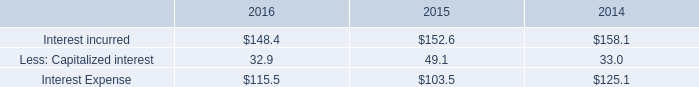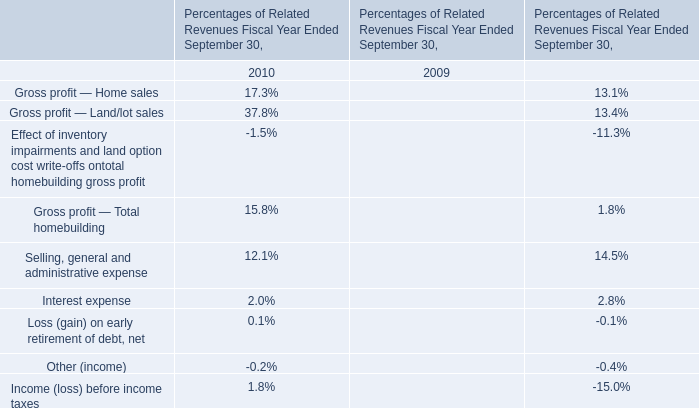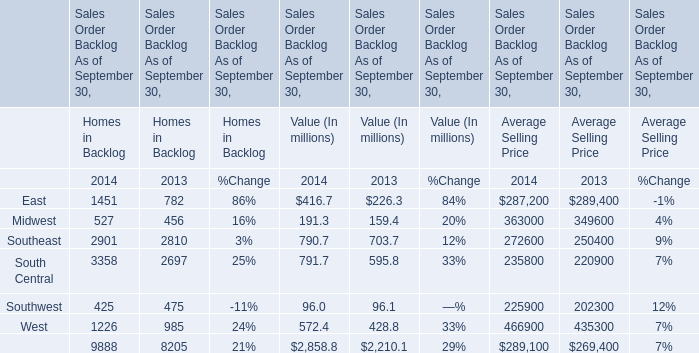What was the total amount of East and Midwest of Homes in Backlog in 2014? (in million) 
Computations: (1451 + 527)
Answer: 1978.0. What will East of Homes in Backlog be like in 2015 if it develops with the same increasing rate as 2014? (in million) 
Computations: (1451 * (1 + ((1451 - 782) / 782)))
Answer: 2692.32864. What's the 2014 increasing rate of East of Homes in Backlog? 
Computations: ((1451 - 782) / 782)
Answer: 0.8555. 